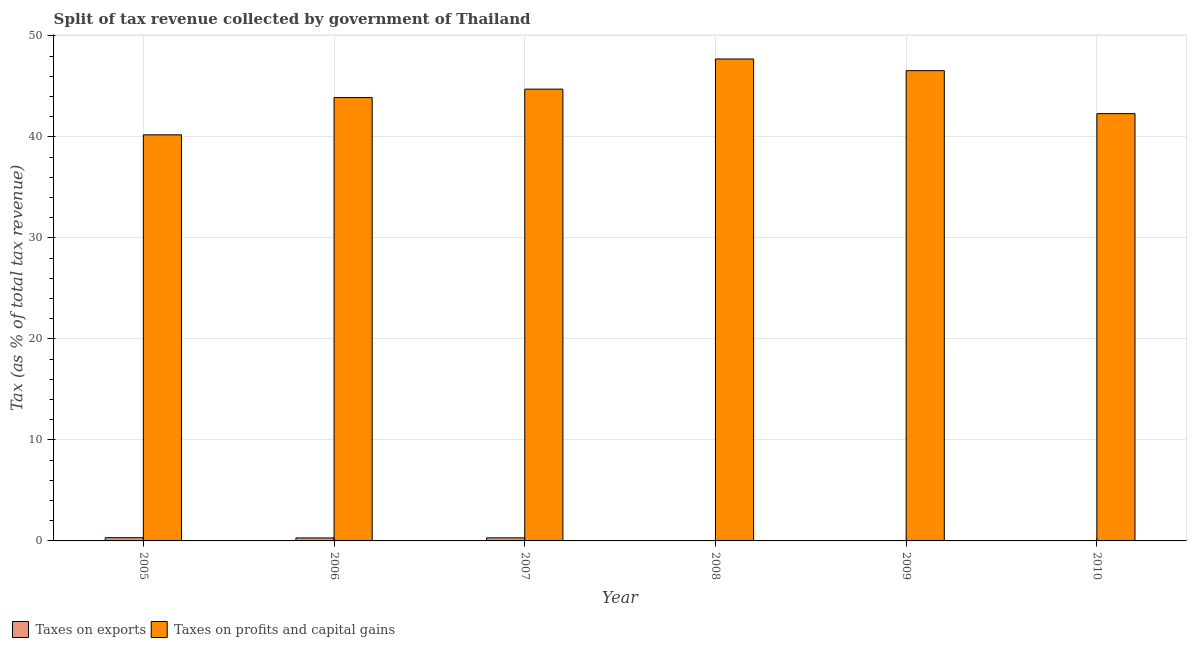How many different coloured bars are there?
Offer a very short reply. 2. In how many cases, is the number of bars for a given year not equal to the number of legend labels?
Your answer should be compact. 0. What is the percentage of revenue obtained from taxes on profits and capital gains in 2005?
Provide a succinct answer. 40.21. Across all years, what is the maximum percentage of revenue obtained from taxes on profits and capital gains?
Provide a short and direct response. 47.72. Across all years, what is the minimum percentage of revenue obtained from taxes on exports?
Offer a terse response. 0.01. What is the total percentage of revenue obtained from taxes on profits and capital gains in the graph?
Provide a succinct answer. 265.45. What is the difference between the percentage of revenue obtained from taxes on exports in 2009 and that in 2010?
Keep it short and to the point. 0.02. What is the difference between the percentage of revenue obtained from taxes on exports in 2005 and the percentage of revenue obtained from taxes on profits and capital gains in 2010?
Keep it short and to the point. 0.31. What is the average percentage of revenue obtained from taxes on profits and capital gains per year?
Ensure brevity in your answer.  44.24. In the year 2007, what is the difference between the percentage of revenue obtained from taxes on exports and percentage of revenue obtained from taxes on profits and capital gains?
Ensure brevity in your answer.  0. What is the ratio of the percentage of revenue obtained from taxes on exports in 2005 to that in 2009?
Your answer should be compact. 10.89. Is the percentage of revenue obtained from taxes on exports in 2006 less than that in 2007?
Offer a very short reply. Yes. What is the difference between the highest and the second highest percentage of revenue obtained from taxes on profits and capital gains?
Your answer should be very brief. 1.16. What is the difference between the highest and the lowest percentage of revenue obtained from taxes on profits and capital gains?
Make the answer very short. 7.51. Is the sum of the percentage of revenue obtained from taxes on profits and capital gains in 2008 and 2010 greater than the maximum percentage of revenue obtained from taxes on exports across all years?
Give a very brief answer. Yes. What does the 2nd bar from the left in 2008 represents?
Offer a terse response. Taxes on profits and capital gains. What does the 2nd bar from the right in 2008 represents?
Provide a succinct answer. Taxes on exports. How many bars are there?
Provide a short and direct response. 12. Are all the bars in the graph horizontal?
Your answer should be very brief. No. How many years are there in the graph?
Your answer should be very brief. 6. Are the values on the major ticks of Y-axis written in scientific E-notation?
Offer a very short reply. No. Does the graph contain grids?
Offer a very short reply. Yes. How are the legend labels stacked?
Offer a very short reply. Horizontal. What is the title of the graph?
Give a very brief answer. Split of tax revenue collected by government of Thailand. What is the label or title of the X-axis?
Your answer should be very brief. Year. What is the label or title of the Y-axis?
Offer a terse response. Tax (as % of total tax revenue). What is the Tax (as % of total tax revenue) of Taxes on exports in 2005?
Your answer should be compact. 0.32. What is the Tax (as % of total tax revenue) of Taxes on profits and capital gains in 2005?
Your answer should be compact. 40.21. What is the Tax (as % of total tax revenue) in Taxes on exports in 2006?
Your answer should be compact. 0.3. What is the Tax (as % of total tax revenue) in Taxes on profits and capital gains in 2006?
Keep it short and to the point. 43.9. What is the Tax (as % of total tax revenue) of Taxes on exports in 2007?
Ensure brevity in your answer.  0.3. What is the Tax (as % of total tax revenue) of Taxes on profits and capital gains in 2007?
Provide a succinct answer. 44.74. What is the Tax (as % of total tax revenue) of Taxes on exports in 2008?
Give a very brief answer. 0.03. What is the Tax (as % of total tax revenue) in Taxes on profits and capital gains in 2008?
Offer a terse response. 47.72. What is the Tax (as % of total tax revenue) in Taxes on exports in 2009?
Provide a succinct answer. 0.03. What is the Tax (as % of total tax revenue) of Taxes on profits and capital gains in 2009?
Make the answer very short. 46.57. What is the Tax (as % of total tax revenue) of Taxes on exports in 2010?
Your answer should be very brief. 0.01. What is the Tax (as % of total tax revenue) of Taxes on profits and capital gains in 2010?
Your answer should be very brief. 42.31. Across all years, what is the maximum Tax (as % of total tax revenue) in Taxes on exports?
Offer a terse response. 0.32. Across all years, what is the maximum Tax (as % of total tax revenue) in Taxes on profits and capital gains?
Your response must be concise. 47.72. Across all years, what is the minimum Tax (as % of total tax revenue) of Taxes on exports?
Give a very brief answer. 0.01. Across all years, what is the minimum Tax (as % of total tax revenue) of Taxes on profits and capital gains?
Keep it short and to the point. 40.21. What is the total Tax (as % of total tax revenue) in Taxes on exports in the graph?
Keep it short and to the point. 0.99. What is the total Tax (as % of total tax revenue) of Taxes on profits and capital gains in the graph?
Provide a succinct answer. 265.45. What is the difference between the Tax (as % of total tax revenue) in Taxes on exports in 2005 and that in 2006?
Offer a terse response. 0.02. What is the difference between the Tax (as % of total tax revenue) in Taxes on profits and capital gains in 2005 and that in 2006?
Your answer should be compact. -3.69. What is the difference between the Tax (as % of total tax revenue) of Taxes on exports in 2005 and that in 2007?
Provide a succinct answer. 0.01. What is the difference between the Tax (as % of total tax revenue) of Taxes on profits and capital gains in 2005 and that in 2007?
Offer a terse response. -4.53. What is the difference between the Tax (as % of total tax revenue) of Taxes on exports in 2005 and that in 2008?
Your answer should be compact. 0.28. What is the difference between the Tax (as % of total tax revenue) of Taxes on profits and capital gains in 2005 and that in 2008?
Ensure brevity in your answer.  -7.51. What is the difference between the Tax (as % of total tax revenue) in Taxes on exports in 2005 and that in 2009?
Provide a succinct answer. 0.29. What is the difference between the Tax (as % of total tax revenue) of Taxes on profits and capital gains in 2005 and that in 2009?
Provide a succinct answer. -6.35. What is the difference between the Tax (as % of total tax revenue) of Taxes on exports in 2005 and that in 2010?
Your answer should be very brief. 0.31. What is the difference between the Tax (as % of total tax revenue) of Taxes on profits and capital gains in 2005 and that in 2010?
Provide a succinct answer. -2.1. What is the difference between the Tax (as % of total tax revenue) in Taxes on exports in 2006 and that in 2007?
Your response must be concise. -0.01. What is the difference between the Tax (as % of total tax revenue) in Taxes on profits and capital gains in 2006 and that in 2007?
Make the answer very short. -0.84. What is the difference between the Tax (as % of total tax revenue) in Taxes on exports in 2006 and that in 2008?
Offer a very short reply. 0.26. What is the difference between the Tax (as % of total tax revenue) in Taxes on profits and capital gains in 2006 and that in 2008?
Your response must be concise. -3.82. What is the difference between the Tax (as % of total tax revenue) in Taxes on exports in 2006 and that in 2009?
Keep it short and to the point. 0.27. What is the difference between the Tax (as % of total tax revenue) of Taxes on profits and capital gains in 2006 and that in 2009?
Provide a succinct answer. -2.67. What is the difference between the Tax (as % of total tax revenue) in Taxes on exports in 2006 and that in 2010?
Ensure brevity in your answer.  0.28. What is the difference between the Tax (as % of total tax revenue) in Taxes on profits and capital gains in 2006 and that in 2010?
Keep it short and to the point. 1.59. What is the difference between the Tax (as % of total tax revenue) of Taxes on exports in 2007 and that in 2008?
Offer a terse response. 0.27. What is the difference between the Tax (as % of total tax revenue) in Taxes on profits and capital gains in 2007 and that in 2008?
Ensure brevity in your answer.  -2.99. What is the difference between the Tax (as % of total tax revenue) in Taxes on exports in 2007 and that in 2009?
Provide a succinct answer. 0.27. What is the difference between the Tax (as % of total tax revenue) of Taxes on profits and capital gains in 2007 and that in 2009?
Your response must be concise. -1.83. What is the difference between the Tax (as % of total tax revenue) of Taxes on exports in 2007 and that in 2010?
Offer a terse response. 0.29. What is the difference between the Tax (as % of total tax revenue) in Taxes on profits and capital gains in 2007 and that in 2010?
Offer a very short reply. 2.43. What is the difference between the Tax (as % of total tax revenue) in Taxes on exports in 2008 and that in 2009?
Keep it short and to the point. 0. What is the difference between the Tax (as % of total tax revenue) in Taxes on profits and capital gains in 2008 and that in 2009?
Ensure brevity in your answer.  1.16. What is the difference between the Tax (as % of total tax revenue) in Taxes on exports in 2008 and that in 2010?
Ensure brevity in your answer.  0.02. What is the difference between the Tax (as % of total tax revenue) in Taxes on profits and capital gains in 2008 and that in 2010?
Keep it short and to the point. 5.41. What is the difference between the Tax (as % of total tax revenue) of Taxes on exports in 2009 and that in 2010?
Provide a succinct answer. 0.02. What is the difference between the Tax (as % of total tax revenue) of Taxes on profits and capital gains in 2009 and that in 2010?
Give a very brief answer. 4.26. What is the difference between the Tax (as % of total tax revenue) in Taxes on exports in 2005 and the Tax (as % of total tax revenue) in Taxes on profits and capital gains in 2006?
Make the answer very short. -43.58. What is the difference between the Tax (as % of total tax revenue) in Taxes on exports in 2005 and the Tax (as % of total tax revenue) in Taxes on profits and capital gains in 2007?
Offer a very short reply. -44.42. What is the difference between the Tax (as % of total tax revenue) of Taxes on exports in 2005 and the Tax (as % of total tax revenue) of Taxes on profits and capital gains in 2008?
Your answer should be very brief. -47.41. What is the difference between the Tax (as % of total tax revenue) of Taxes on exports in 2005 and the Tax (as % of total tax revenue) of Taxes on profits and capital gains in 2009?
Your answer should be very brief. -46.25. What is the difference between the Tax (as % of total tax revenue) of Taxes on exports in 2005 and the Tax (as % of total tax revenue) of Taxes on profits and capital gains in 2010?
Offer a terse response. -41.99. What is the difference between the Tax (as % of total tax revenue) in Taxes on exports in 2006 and the Tax (as % of total tax revenue) in Taxes on profits and capital gains in 2007?
Provide a succinct answer. -44.44. What is the difference between the Tax (as % of total tax revenue) of Taxes on exports in 2006 and the Tax (as % of total tax revenue) of Taxes on profits and capital gains in 2008?
Offer a terse response. -47.43. What is the difference between the Tax (as % of total tax revenue) in Taxes on exports in 2006 and the Tax (as % of total tax revenue) in Taxes on profits and capital gains in 2009?
Provide a short and direct response. -46.27. What is the difference between the Tax (as % of total tax revenue) of Taxes on exports in 2006 and the Tax (as % of total tax revenue) of Taxes on profits and capital gains in 2010?
Make the answer very short. -42.01. What is the difference between the Tax (as % of total tax revenue) in Taxes on exports in 2007 and the Tax (as % of total tax revenue) in Taxes on profits and capital gains in 2008?
Your response must be concise. -47.42. What is the difference between the Tax (as % of total tax revenue) in Taxes on exports in 2007 and the Tax (as % of total tax revenue) in Taxes on profits and capital gains in 2009?
Keep it short and to the point. -46.26. What is the difference between the Tax (as % of total tax revenue) of Taxes on exports in 2007 and the Tax (as % of total tax revenue) of Taxes on profits and capital gains in 2010?
Provide a succinct answer. -42.01. What is the difference between the Tax (as % of total tax revenue) of Taxes on exports in 2008 and the Tax (as % of total tax revenue) of Taxes on profits and capital gains in 2009?
Your answer should be compact. -46.53. What is the difference between the Tax (as % of total tax revenue) of Taxes on exports in 2008 and the Tax (as % of total tax revenue) of Taxes on profits and capital gains in 2010?
Provide a succinct answer. -42.28. What is the difference between the Tax (as % of total tax revenue) of Taxes on exports in 2009 and the Tax (as % of total tax revenue) of Taxes on profits and capital gains in 2010?
Keep it short and to the point. -42.28. What is the average Tax (as % of total tax revenue) of Taxes on exports per year?
Give a very brief answer. 0.16. What is the average Tax (as % of total tax revenue) of Taxes on profits and capital gains per year?
Provide a succinct answer. 44.24. In the year 2005, what is the difference between the Tax (as % of total tax revenue) in Taxes on exports and Tax (as % of total tax revenue) in Taxes on profits and capital gains?
Give a very brief answer. -39.89. In the year 2006, what is the difference between the Tax (as % of total tax revenue) in Taxes on exports and Tax (as % of total tax revenue) in Taxes on profits and capital gains?
Make the answer very short. -43.6. In the year 2007, what is the difference between the Tax (as % of total tax revenue) of Taxes on exports and Tax (as % of total tax revenue) of Taxes on profits and capital gains?
Provide a short and direct response. -44.43. In the year 2008, what is the difference between the Tax (as % of total tax revenue) of Taxes on exports and Tax (as % of total tax revenue) of Taxes on profits and capital gains?
Give a very brief answer. -47.69. In the year 2009, what is the difference between the Tax (as % of total tax revenue) of Taxes on exports and Tax (as % of total tax revenue) of Taxes on profits and capital gains?
Your response must be concise. -46.54. In the year 2010, what is the difference between the Tax (as % of total tax revenue) of Taxes on exports and Tax (as % of total tax revenue) of Taxes on profits and capital gains?
Your response must be concise. -42.3. What is the ratio of the Tax (as % of total tax revenue) of Taxes on exports in 2005 to that in 2006?
Make the answer very short. 1.08. What is the ratio of the Tax (as % of total tax revenue) of Taxes on profits and capital gains in 2005 to that in 2006?
Give a very brief answer. 0.92. What is the ratio of the Tax (as % of total tax revenue) in Taxes on exports in 2005 to that in 2007?
Give a very brief answer. 1.05. What is the ratio of the Tax (as % of total tax revenue) of Taxes on profits and capital gains in 2005 to that in 2007?
Provide a succinct answer. 0.9. What is the ratio of the Tax (as % of total tax revenue) of Taxes on exports in 2005 to that in 2008?
Ensure brevity in your answer.  9.49. What is the ratio of the Tax (as % of total tax revenue) in Taxes on profits and capital gains in 2005 to that in 2008?
Your answer should be compact. 0.84. What is the ratio of the Tax (as % of total tax revenue) in Taxes on exports in 2005 to that in 2009?
Your answer should be compact. 10.89. What is the ratio of the Tax (as % of total tax revenue) of Taxes on profits and capital gains in 2005 to that in 2009?
Provide a succinct answer. 0.86. What is the ratio of the Tax (as % of total tax revenue) of Taxes on exports in 2005 to that in 2010?
Provide a succinct answer. 30.63. What is the ratio of the Tax (as % of total tax revenue) of Taxes on profits and capital gains in 2005 to that in 2010?
Keep it short and to the point. 0.95. What is the ratio of the Tax (as % of total tax revenue) in Taxes on exports in 2006 to that in 2007?
Your answer should be compact. 0.97. What is the ratio of the Tax (as % of total tax revenue) of Taxes on profits and capital gains in 2006 to that in 2007?
Your answer should be compact. 0.98. What is the ratio of the Tax (as % of total tax revenue) of Taxes on exports in 2006 to that in 2008?
Offer a very short reply. 8.82. What is the ratio of the Tax (as % of total tax revenue) of Taxes on profits and capital gains in 2006 to that in 2008?
Make the answer very short. 0.92. What is the ratio of the Tax (as % of total tax revenue) of Taxes on exports in 2006 to that in 2009?
Give a very brief answer. 10.12. What is the ratio of the Tax (as % of total tax revenue) of Taxes on profits and capital gains in 2006 to that in 2009?
Provide a succinct answer. 0.94. What is the ratio of the Tax (as % of total tax revenue) of Taxes on exports in 2006 to that in 2010?
Your answer should be very brief. 28.46. What is the ratio of the Tax (as % of total tax revenue) in Taxes on profits and capital gains in 2006 to that in 2010?
Your answer should be very brief. 1.04. What is the ratio of the Tax (as % of total tax revenue) in Taxes on exports in 2007 to that in 2008?
Ensure brevity in your answer.  9.05. What is the ratio of the Tax (as % of total tax revenue) in Taxes on profits and capital gains in 2007 to that in 2008?
Your response must be concise. 0.94. What is the ratio of the Tax (as % of total tax revenue) in Taxes on exports in 2007 to that in 2009?
Provide a short and direct response. 10.38. What is the ratio of the Tax (as % of total tax revenue) in Taxes on profits and capital gains in 2007 to that in 2009?
Your answer should be compact. 0.96. What is the ratio of the Tax (as % of total tax revenue) of Taxes on exports in 2007 to that in 2010?
Your answer should be very brief. 29.19. What is the ratio of the Tax (as % of total tax revenue) of Taxes on profits and capital gains in 2007 to that in 2010?
Keep it short and to the point. 1.06. What is the ratio of the Tax (as % of total tax revenue) of Taxes on exports in 2008 to that in 2009?
Give a very brief answer. 1.15. What is the ratio of the Tax (as % of total tax revenue) in Taxes on profits and capital gains in 2008 to that in 2009?
Give a very brief answer. 1.02. What is the ratio of the Tax (as % of total tax revenue) in Taxes on exports in 2008 to that in 2010?
Provide a short and direct response. 3.23. What is the ratio of the Tax (as % of total tax revenue) in Taxes on profits and capital gains in 2008 to that in 2010?
Your response must be concise. 1.13. What is the ratio of the Tax (as % of total tax revenue) in Taxes on exports in 2009 to that in 2010?
Give a very brief answer. 2.81. What is the ratio of the Tax (as % of total tax revenue) in Taxes on profits and capital gains in 2009 to that in 2010?
Give a very brief answer. 1.1. What is the difference between the highest and the second highest Tax (as % of total tax revenue) in Taxes on exports?
Make the answer very short. 0.01. What is the difference between the highest and the second highest Tax (as % of total tax revenue) in Taxes on profits and capital gains?
Ensure brevity in your answer.  1.16. What is the difference between the highest and the lowest Tax (as % of total tax revenue) of Taxes on exports?
Keep it short and to the point. 0.31. What is the difference between the highest and the lowest Tax (as % of total tax revenue) of Taxes on profits and capital gains?
Your response must be concise. 7.51. 